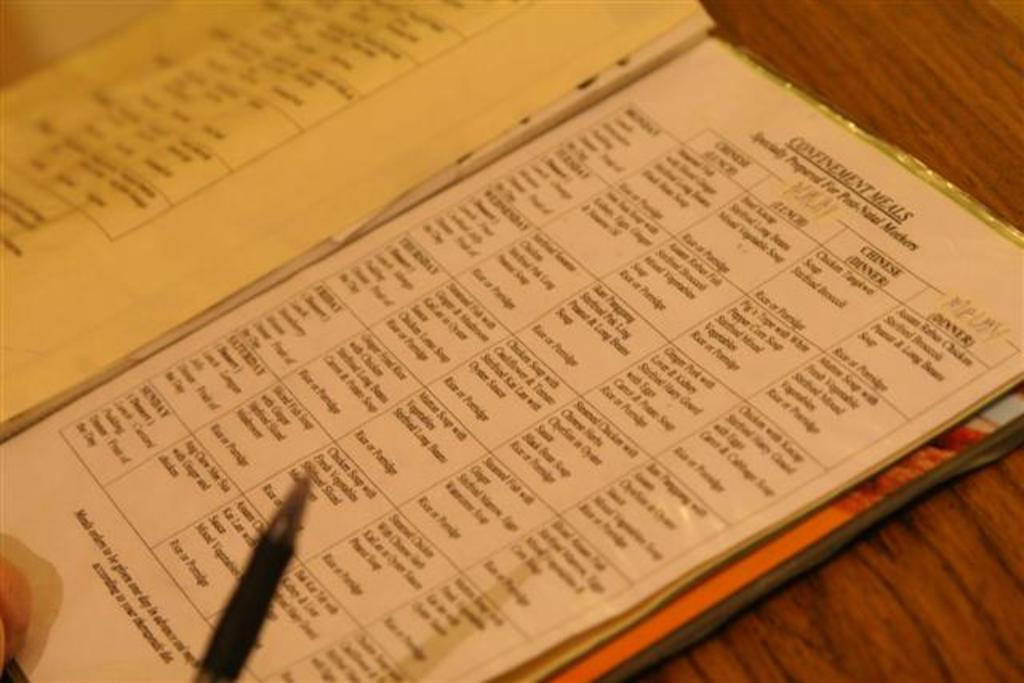Provide a one-sentence caption for the provided image. A menu list that is labeled confinement meals. 